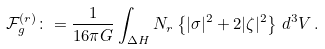<formula> <loc_0><loc_0><loc_500><loc_500>\mathcal { F } ^ { ( r ) } _ { g } \colon = \frac { 1 } { 1 6 \pi G } \int _ { \Delta H } N _ { r } \left \{ | \sigma | ^ { 2 } + 2 | \zeta | ^ { 2 } \right \} \, d ^ { 3 } V \, .</formula> 